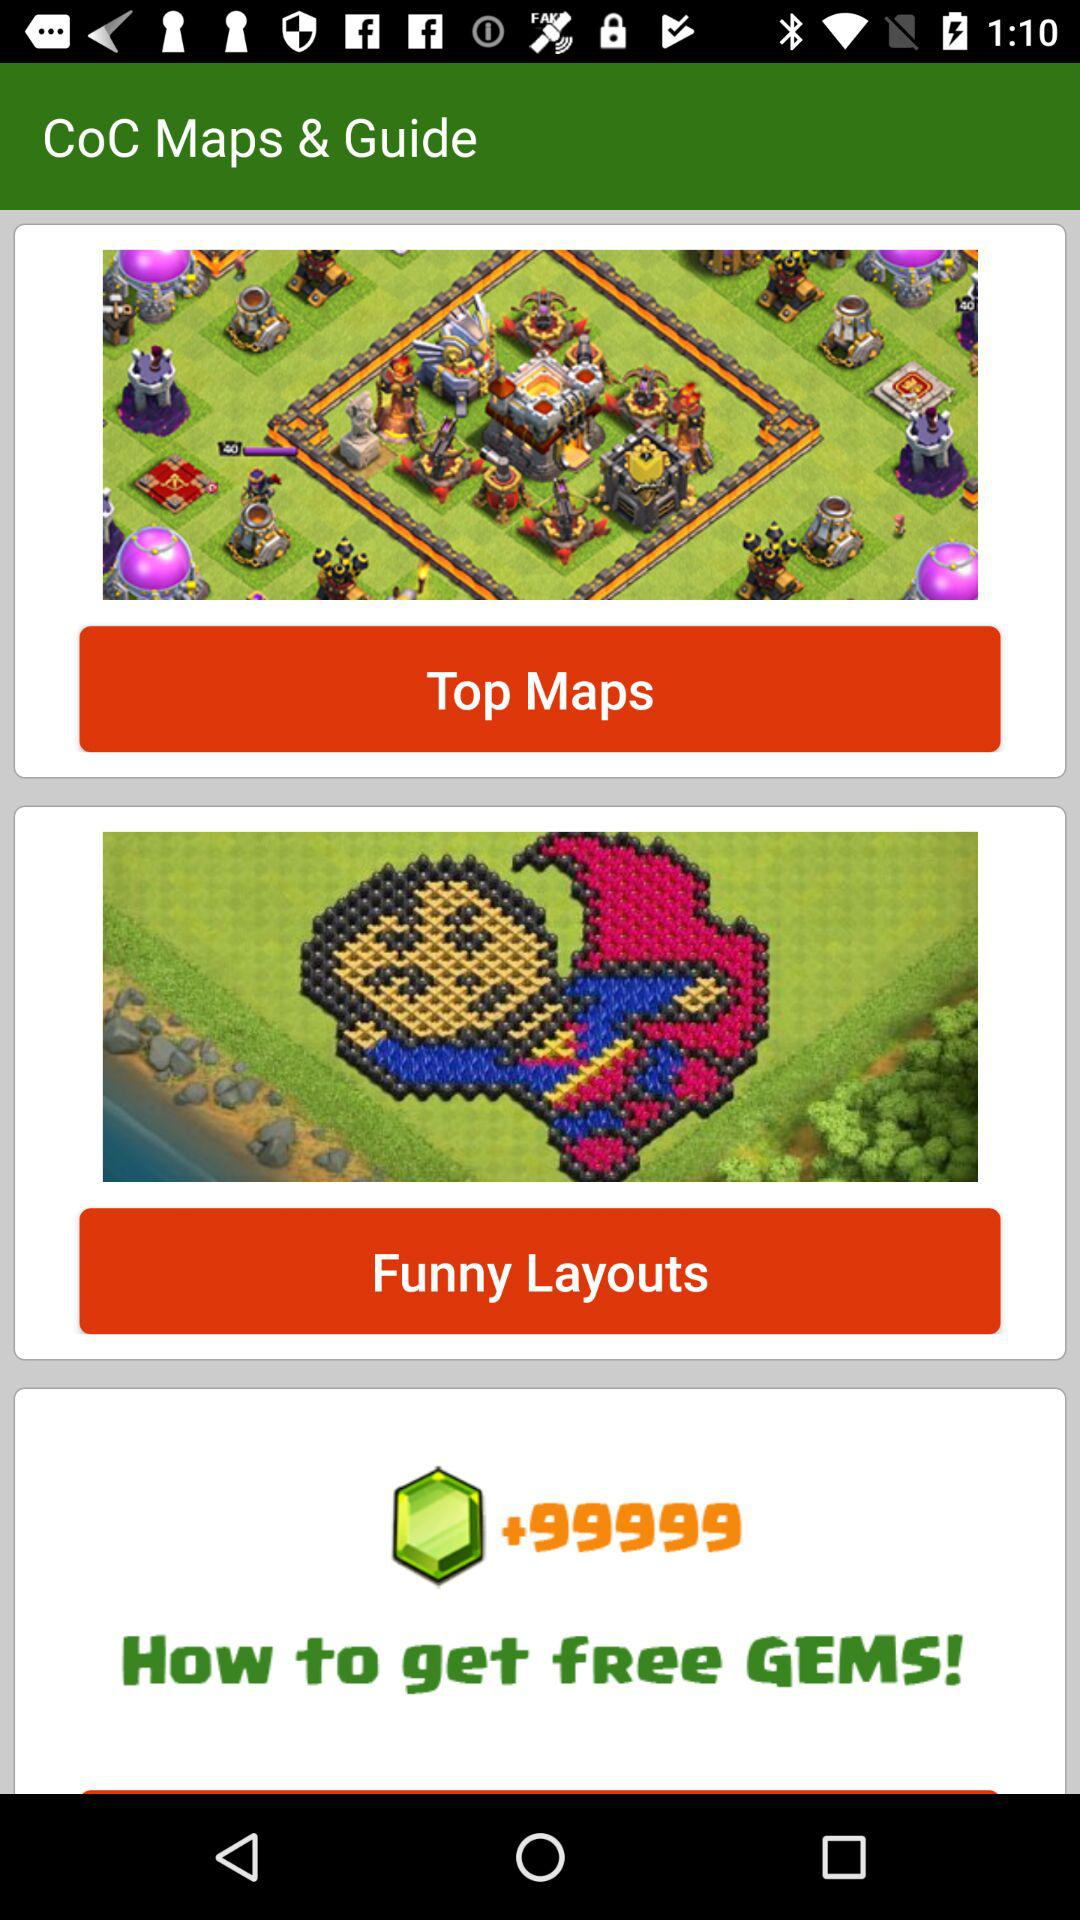What is the app name? The app name is "CoC Maps & Guide". 